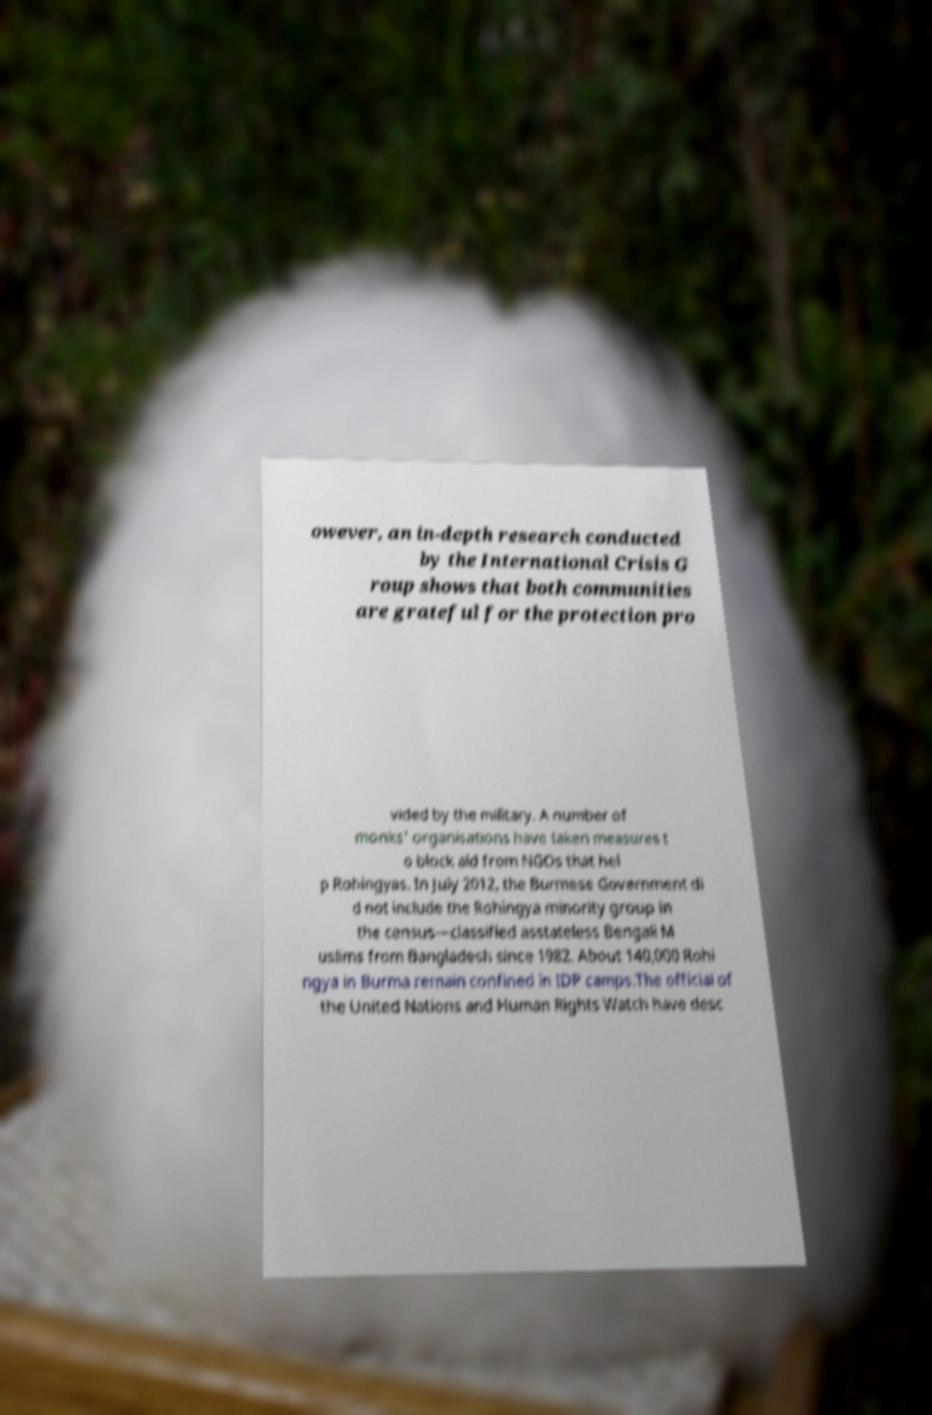Can you read and provide the text displayed in the image?This photo seems to have some interesting text. Can you extract and type it out for me? owever, an in-depth research conducted by the International Crisis G roup shows that both communities are grateful for the protection pro vided by the military. A number of monks' organisations have taken measures t o block aid from NGOs that hel p Rohingyas. In July 2012, the Burmese Government di d not include the Rohingya minority group in the census—classified asstateless Bengali M uslims from Bangladesh since 1982. About 140,000 Rohi ngya in Burma remain confined in IDP camps.The official of the United Nations and Human Rights Watch have desc 